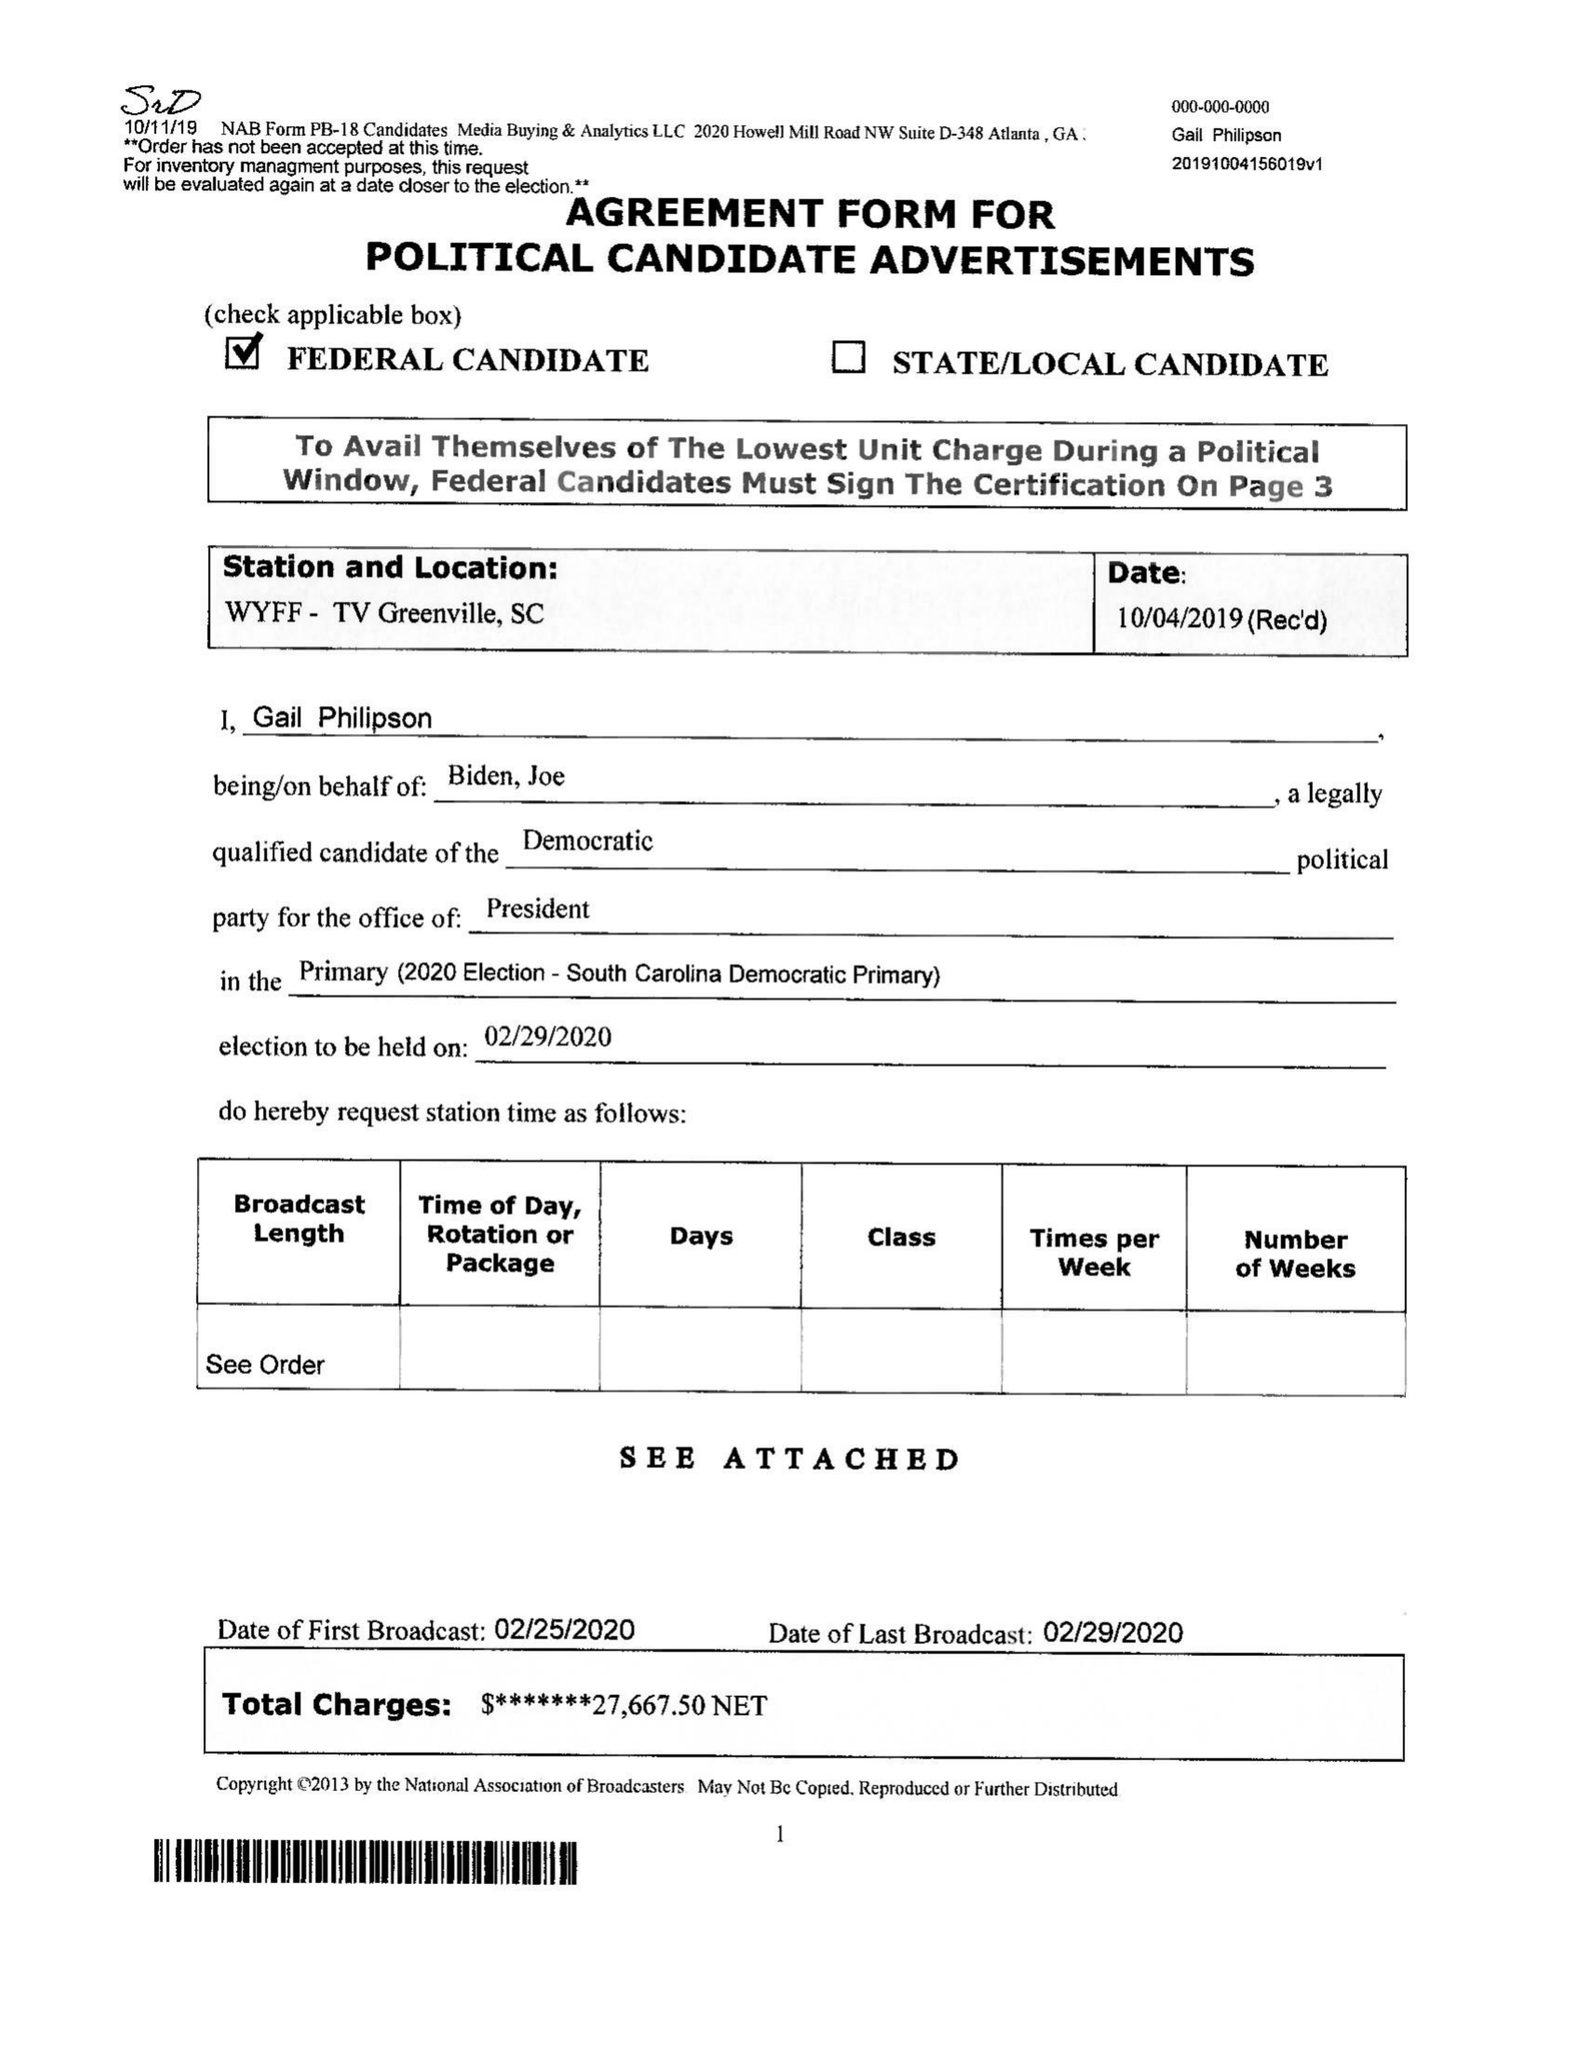What is the value for the advertiser?
Answer the question using a single word or phrase. BIDEN FOR PRESIDENT 